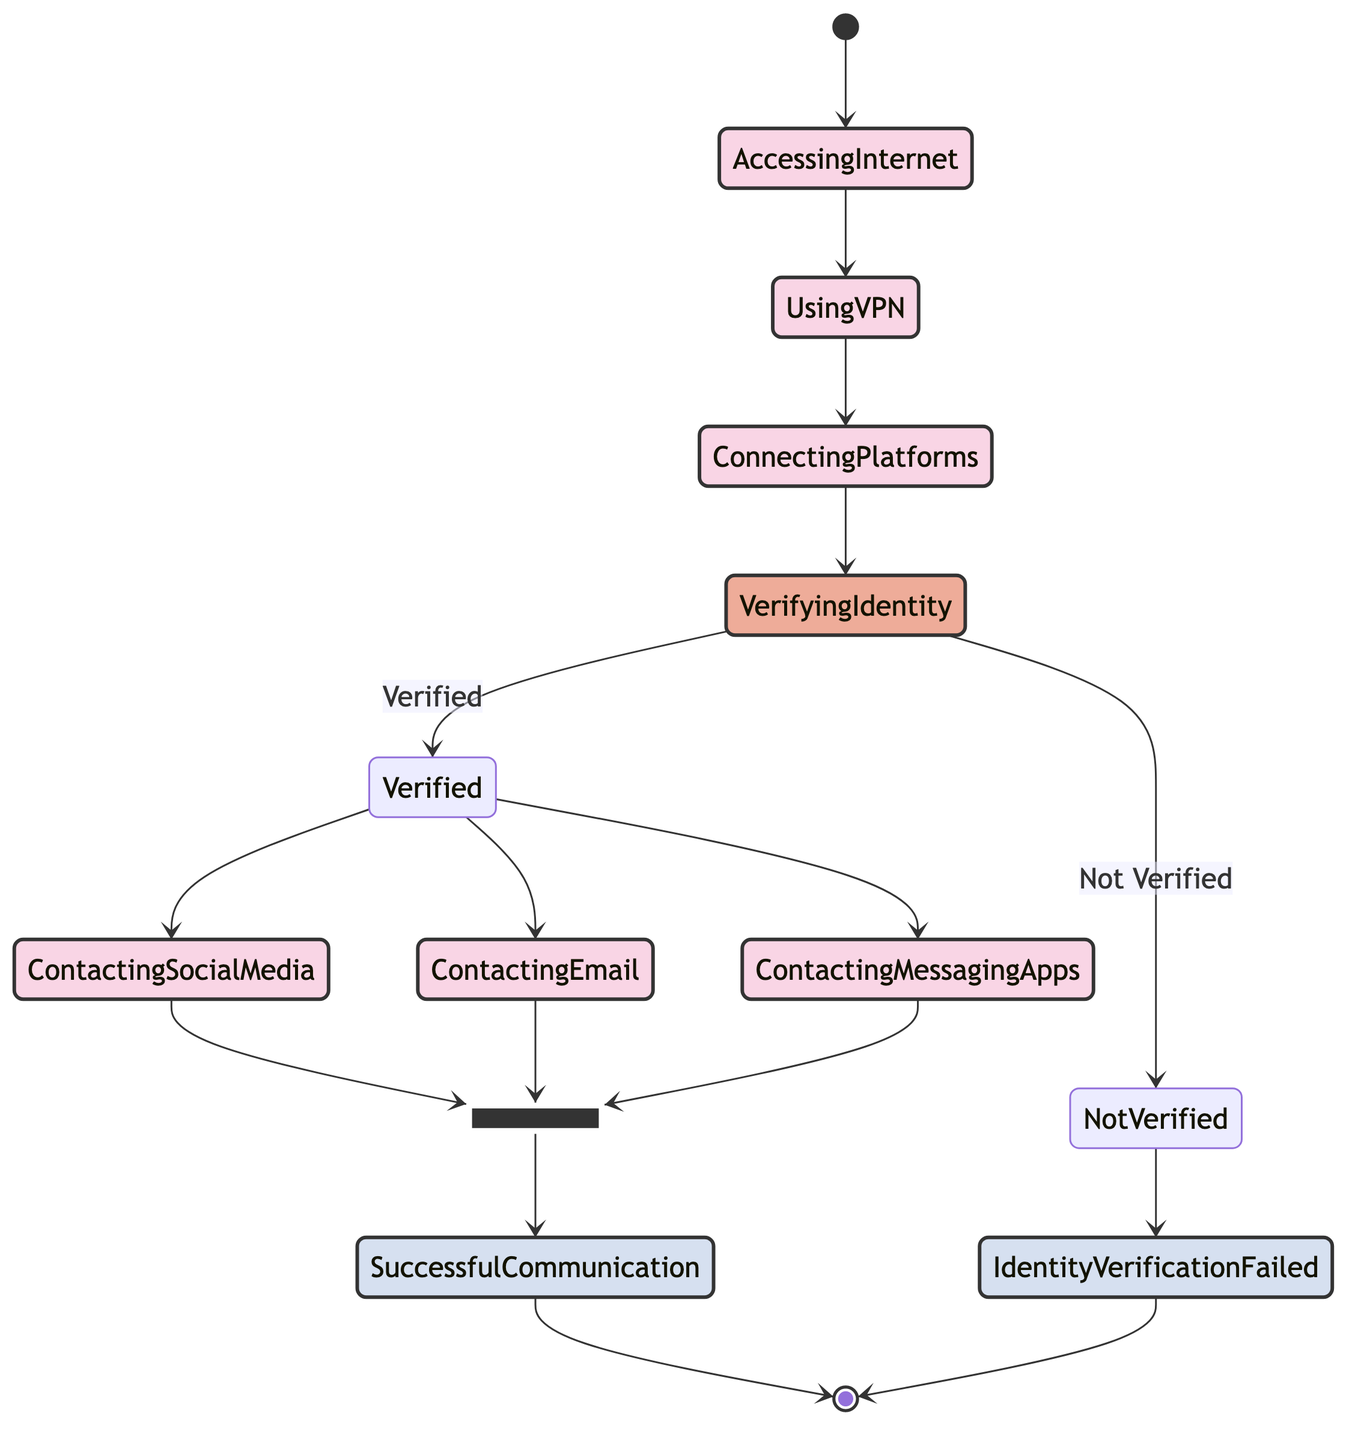What is the first action in the diagram? The first action in the diagram is indicated by the arrow pointing from the start state to "Accessing the Internet." It signifies the initial step in the process.
Answer: Accessing the Internet How many actions are in the diagram? The diagram includes six actions: "Accessing the Internet," "Using VPN for Secure Connection," "Connecting to Communication Platforms," "Contacting via Social Media," "Contacting via Email," and "Contacting via Messaging Apps." By counting these nodes, the answer can be determined.
Answer: Six What happens if the identity is not verified? If the identity is not verified, the flow leads to the node "Identity Verification Failed," indicating that the communication cannot be established. The decision node shows this path specifically.
Answer: Identity Verification Failed What are the methods of contacting established after verification? After successful verification, the established methods for contacting are "Contacting via Social Media," "Contacting via Email," and "Contacting via Messaging Apps." These nodes branch out from the verified decision node, indicating the options available.
Answer: Contacting via Social Media, Contacting via Email, Contacting via Messaging Apps What is the relationship between "Using VPN for Secure Connection" and "Connecting to Communication Platforms"? The relationship is sequential; "Using VPN for Secure Connection" directly leads to "Connecting to Communication Platforms." This indicates that the connection to platforms can only happen after establishing a VPN.
Answer: Sequential What is the last action before successful communication is established? The last actions before reaching "Successful Communication Established" are the three methods of contacting: "Contacting via Social Media," "Contacting via Email," and "Contacting via Messaging Apps." All three lead into the successful communication node.
Answer: Contacting via Social Media, Contacting via Email, Contacting via Messaging Apps What indicates a successful outcome in the diagram? A successful outcome is indicated by reaching the node "Successful Communication Established," which is an end state of the diagram that signifies the completion of the communication process.
Answer: Successful Communication Established 